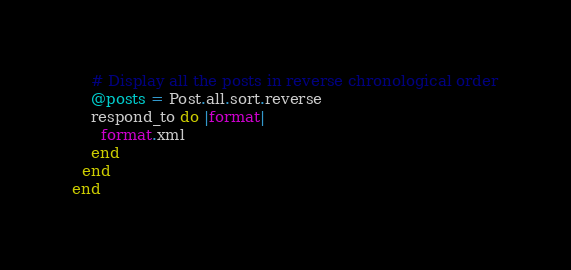<code> <loc_0><loc_0><loc_500><loc_500><_Ruby_>    # Display all the posts in reverse chronological order
    @posts = Post.all.sort.reverse
    respond_to do |format|
      format.xml
    end
  end
end
</code> 